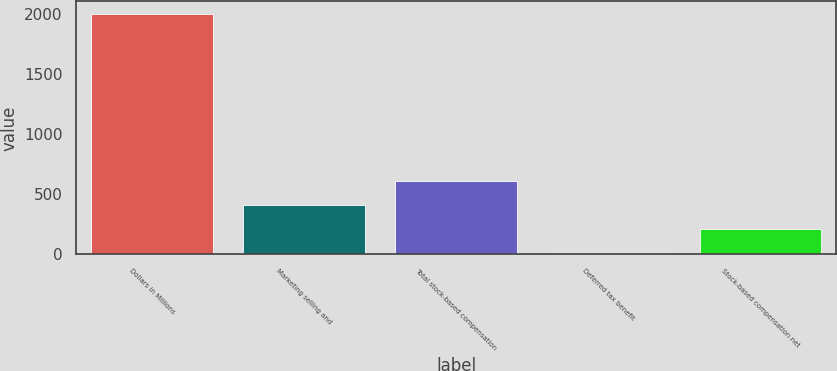Convert chart to OTSL. <chart><loc_0><loc_0><loc_500><loc_500><bar_chart><fcel>Dollars in Millions<fcel>Marketing selling and<fcel>Total stock-based compensation<fcel>Deferred tax benefit<fcel>Stock-based compensation net<nl><fcel>2005<fcel>409.8<fcel>609.2<fcel>11<fcel>210.4<nl></chart> 